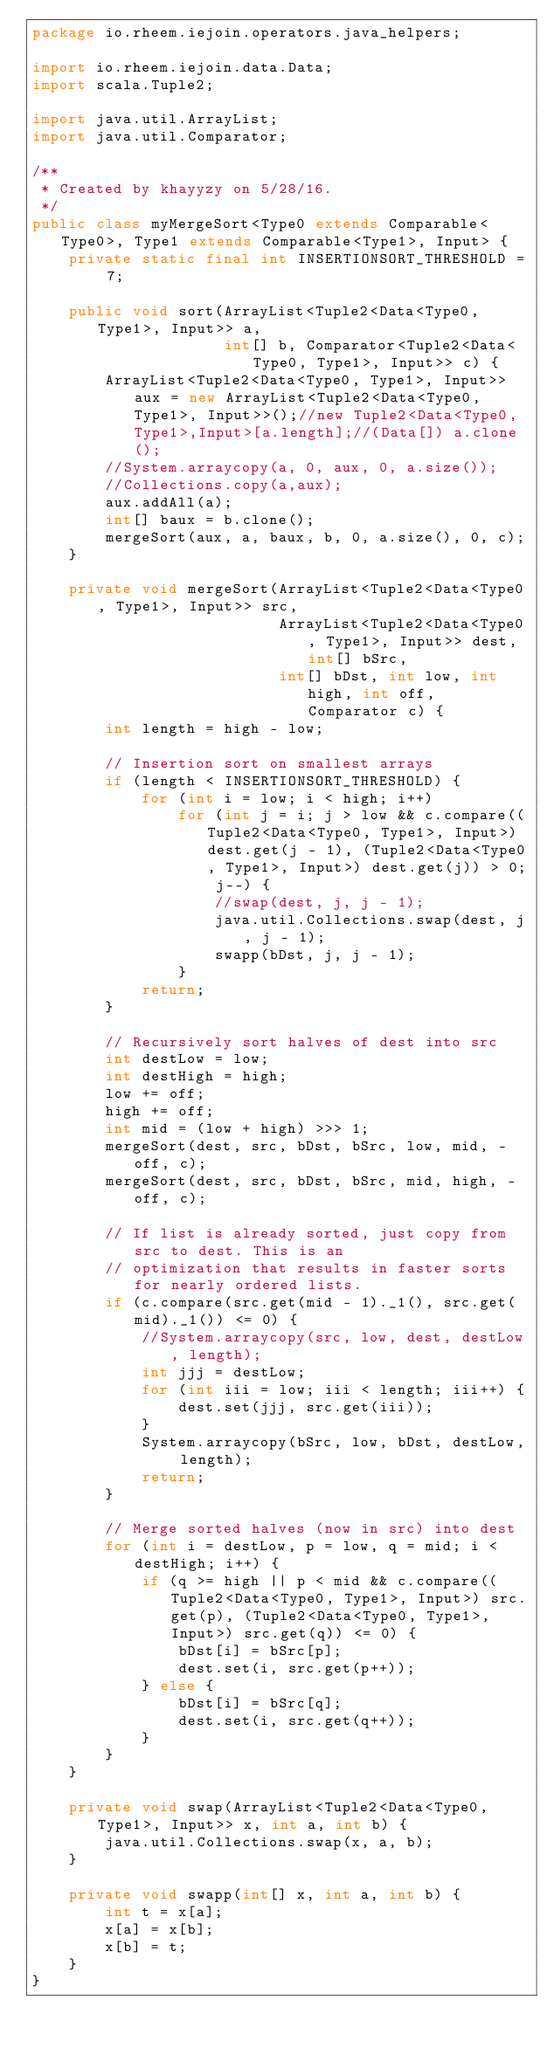Convert code to text. <code><loc_0><loc_0><loc_500><loc_500><_Java_>package io.rheem.iejoin.operators.java_helpers;

import io.rheem.iejoin.data.Data;
import scala.Tuple2;

import java.util.ArrayList;
import java.util.Comparator;

/**
 * Created by khayyzy on 5/28/16.
 */
public class myMergeSort<Type0 extends Comparable<Type0>, Type1 extends Comparable<Type1>, Input> {
    private static final int INSERTIONSORT_THRESHOLD = 7;

    public void sort(ArrayList<Tuple2<Data<Type0, Type1>, Input>> a,
                     int[] b, Comparator<Tuple2<Data<Type0, Type1>, Input>> c) {
        ArrayList<Tuple2<Data<Type0, Type1>, Input>> aux = new ArrayList<Tuple2<Data<Type0, Type1>, Input>>();//new Tuple2<Data<Type0,Type1>,Input>[a.length];//(Data[]) a.clone();
        //System.arraycopy(a, 0, aux, 0, a.size());
        //Collections.copy(a,aux);
        aux.addAll(a);
        int[] baux = b.clone();
        mergeSort(aux, a, baux, b, 0, a.size(), 0, c);
    }

    private void mergeSort(ArrayList<Tuple2<Data<Type0, Type1>, Input>> src,
                           ArrayList<Tuple2<Data<Type0, Type1>, Input>> dest, int[] bSrc,
                           int[] bDst, int low, int high, int off, Comparator c) {
        int length = high - low;

        // Insertion sort on smallest arrays
        if (length < INSERTIONSORT_THRESHOLD) {
            for (int i = low; i < high; i++)
                for (int j = i; j > low && c.compare((Tuple2<Data<Type0, Type1>, Input>) dest.get(j - 1), (Tuple2<Data<Type0, Type1>, Input>) dest.get(j)) > 0; j--) {
                    //swap(dest, j, j - 1);
                    java.util.Collections.swap(dest, j, j - 1);
                    swapp(bDst, j, j - 1);
                }
            return;
        }

        // Recursively sort halves of dest into src
        int destLow = low;
        int destHigh = high;
        low += off;
        high += off;
        int mid = (low + high) >>> 1;
        mergeSort(dest, src, bDst, bSrc, low, mid, -off, c);
        mergeSort(dest, src, bDst, bSrc, mid, high, -off, c);

        // If list is already sorted, just copy from src to dest. This is an
        // optimization that results in faster sorts for nearly ordered lists.
        if (c.compare(src.get(mid - 1)._1(), src.get(mid)._1()) <= 0) {
            //System.arraycopy(src, low, dest, destLow, length);
            int jjj = destLow;
            for (int iii = low; iii < length; iii++) {
                dest.set(jjj, src.get(iii));
            }
            System.arraycopy(bSrc, low, bDst, destLow, length);
            return;
        }

        // Merge sorted halves (now in src) into dest
        for (int i = destLow, p = low, q = mid; i < destHigh; i++) {
            if (q >= high || p < mid && c.compare((Tuple2<Data<Type0, Type1>, Input>) src.get(p), (Tuple2<Data<Type0, Type1>, Input>) src.get(q)) <= 0) {
                bDst[i] = bSrc[p];
                dest.set(i, src.get(p++));
            } else {
                bDst[i] = bSrc[q];
                dest.set(i, src.get(q++));
            }
        }
    }

    private void swap(ArrayList<Tuple2<Data<Type0, Type1>, Input>> x, int a, int b) {
        java.util.Collections.swap(x, a, b);
    }

    private void swapp(int[] x, int a, int b) {
        int t = x[a];
        x[a] = x[b];
        x[b] = t;
    }
}
</code> 